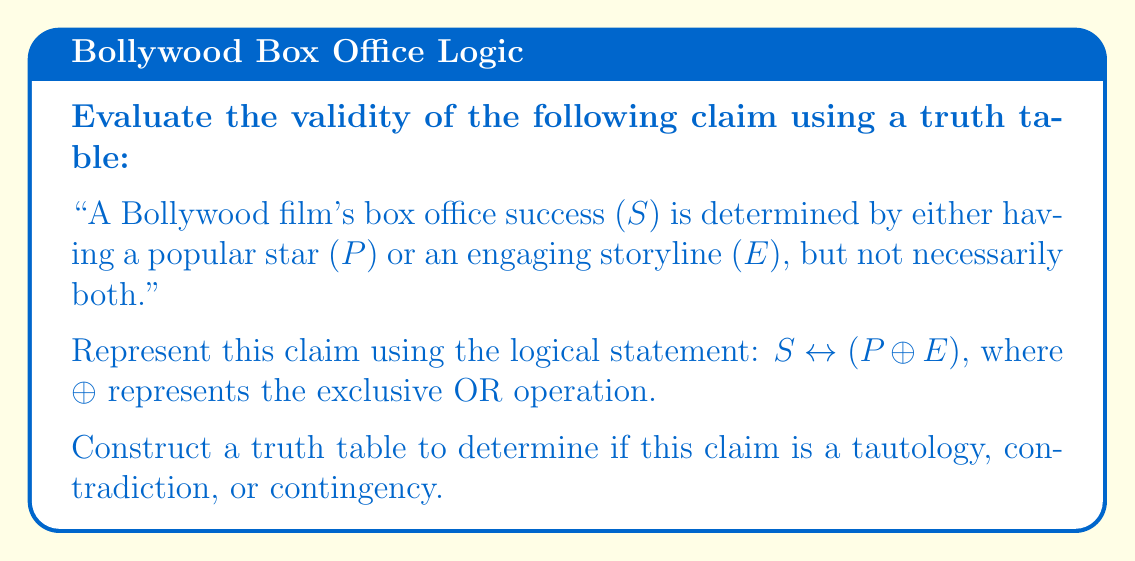Provide a solution to this math problem. Let's approach this step-by-step:

1) First, we need to create a truth table with columns for $P$, $E$, $S$, and the entire statement $S \leftrightarrow (P \oplus E)$.

2) We'll evaluate $P \oplus E$ first, then $S \leftrightarrow (P \oplus E)$.

3) Truth table:

   $$
   \begin{array}{|c|c|c|c|c|}
   \hline
   P & E & P \oplus E & S & S \leftrightarrow (P \oplus E) \\
   \hline
   T & T & F & T & F \\
   T & F & T & T & T \\
   F & T & T & T & T \\
   F & F & F & F & T \\
   \hline
   \end{array}
   $$

4) Explanation of each row:
   - Row 1: When both $P$ and $E$ are true, $P \oplus E$ is false (XOR is false when both inputs are true). If $S$ is true, the overall statement is false.
   - Row 2 & 3: When either $P$ or $E$ (but not both) is true, $P \oplus E$ is true. If $S$ is also true, the overall statement is true.
   - Row 4: When both $P$ and $E$ are false, $P \oplus E$ is false. If $S$ is also false, the overall statement is true.

5) Analysis:
   The truth table shows that the statement is not always true (not a tautology) and not always false (not a contradiction). Therefore, it's a contingency.

6) Interpretation for a film critic:
   This logical analysis reveals that the claim oversimplifies box office success. It correctly identifies some scenarios (rows 2, 3, 4) but fails in the case where a film has both star power and an engaging story (row 1). This aligns with a critic's perspective that Bollywood's reliance on formulaic elements (star power or engaging plot) doesn't guarantee success, and the relationship between these factors and box office performance is more complex than the claim suggests.
Answer: Contingency 